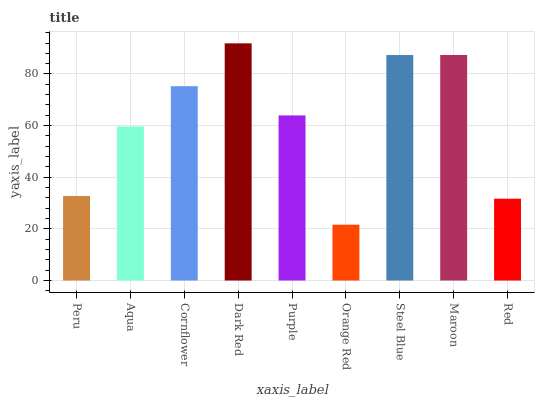Is Orange Red the minimum?
Answer yes or no. Yes. Is Dark Red the maximum?
Answer yes or no. Yes. Is Aqua the minimum?
Answer yes or no. No. Is Aqua the maximum?
Answer yes or no. No. Is Aqua greater than Peru?
Answer yes or no. Yes. Is Peru less than Aqua?
Answer yes or no. Yes. Is Peru greater than Aqua?
Answer yes or no. No. Is Aqua less than Peru?
Answer yes or no. No. Is Purple the high median?
Answer yes or no. Yes. Is Purple the low median?
Answer yes or no. Yes. Is Cornflower the high median?
Answer yes or no. No. Is Peru the low median?
Answer yes or no. No. 